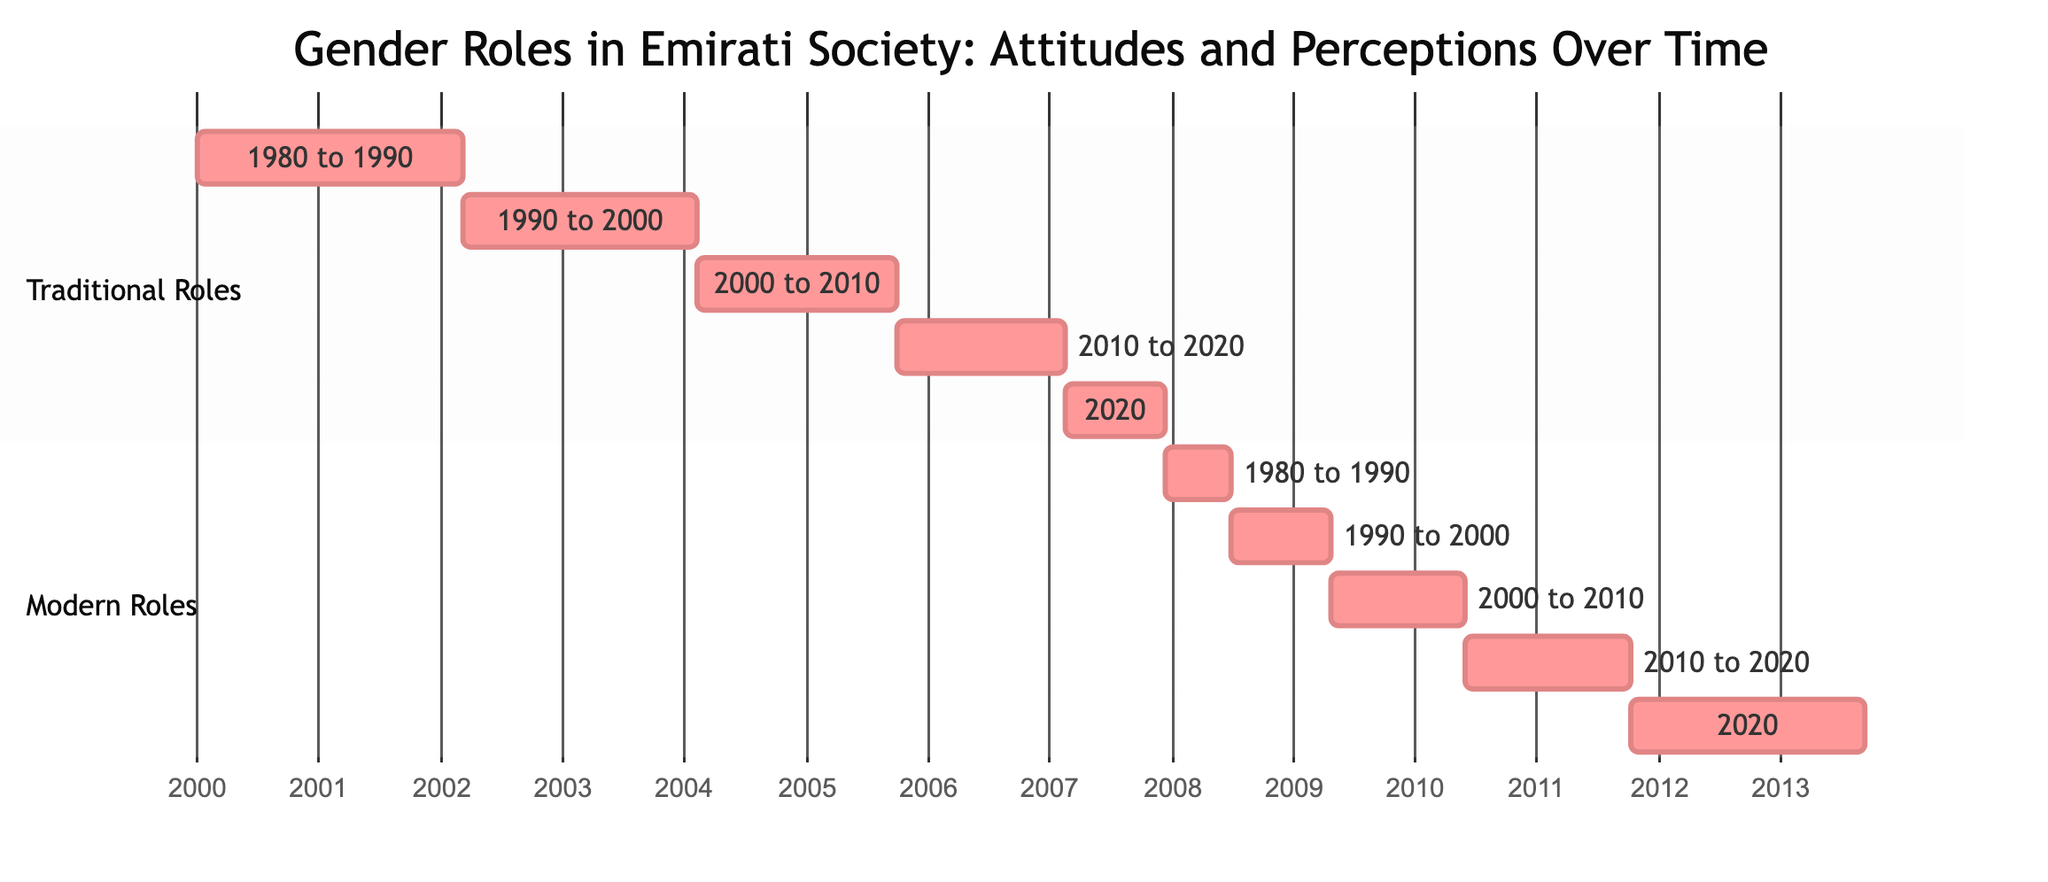What was the traditional role percentage in 2000? In the diagram, the section for traditional roles shows a value of 600d (days) for the year 2000. This indicates a percentage related to traditional gender roles during that decade.
Answer: 600d What is the highest recorded percentage for modern roles? By reviewing the modern roles section of the diagram, the peak value is represented as 700d for the year 2020, indicating the maximum percentage for modern gender roles.
Answer: 700d How did perceptions of traditional roles change from 1990 to 2020? The diagram shows a decrease in traditional roles, from 700d in 1990 to 300d in 2020. This demonstrates a shift in attitudes, representing a decline of 400d over three decades.
Answer: Decreased What is the difference in traditional roles between 1980 and 2010? In 1980, traditional roles were represented by 800d, while in 2010 they were at 500d. The difference is calculated by subtracting 500d from 800d, resulting in a decline of 300d over that period.
Answer: 300d Which period experienced the highest increase in modern roles? Upon examining the modern roles data, the greatest increase occurred from 2010 to 2020, with values going from 500d to 700d, resulting in an increase of 200d.
Answer: 200d What is the total number of segments in the diagram? The diagram features two primary sections: Traditional Roles and Modern Roles. Each section has five time segments, leading to a total of ten segments.
Answer: 10 Which decade showed a consistent perception of modern roles? By analyzing the data in the modern roles section, the numbers from 2000 to 2020 show a consistent increase from 400d to 700d, indicating a steady perception of modern roles over that period.
Answer: 2000 to 2020 What percentage drop occurred in traditional roles from 2000 to 2020? The figure for traditional roles in 2000 is 600d, and this dropped to 300d by 2020. Calculating the drop gives 600d - 300d = 300d, indicating a decline of 300d during that period.
Answer: 300d 